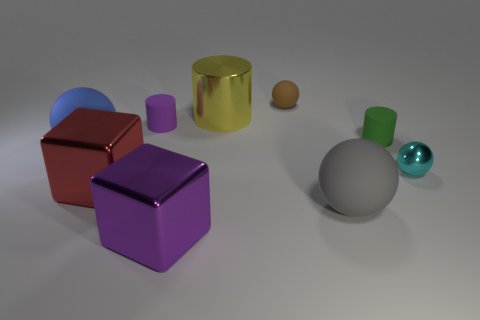What is the shape of the gray object to the left of the metallic object on the right side of the brown matte object? The gray object to the left of the metallic golden cylinder and to the right of the brown cube is indeed a sphere. It's interesting to note how its simple, smooth, and continuous surface contrasts with the other objects in the image, which have definite edges and faces. 